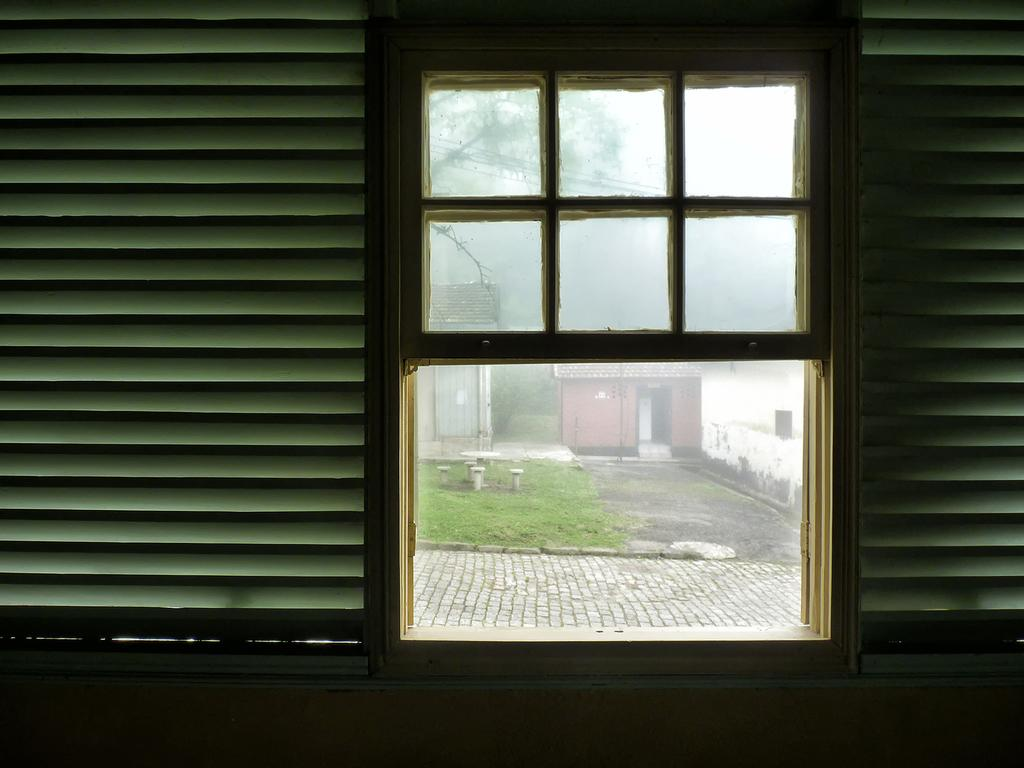What type of space is shown in the image? The image is an inside view of a room. What is one of the main features of the room? There is a wall in the room. What allows natural light to enter the room? There is a window in the room, and it has glass associated with it. What can be seen outside the window? Through the window, sheds, a door, grass, poles, a wall, and a road are visible. What type of shoe is visible in the middle of the room? There is no shoe present in the image. Can you describe the bird that is flying through the room? There is no bird present in the image. 